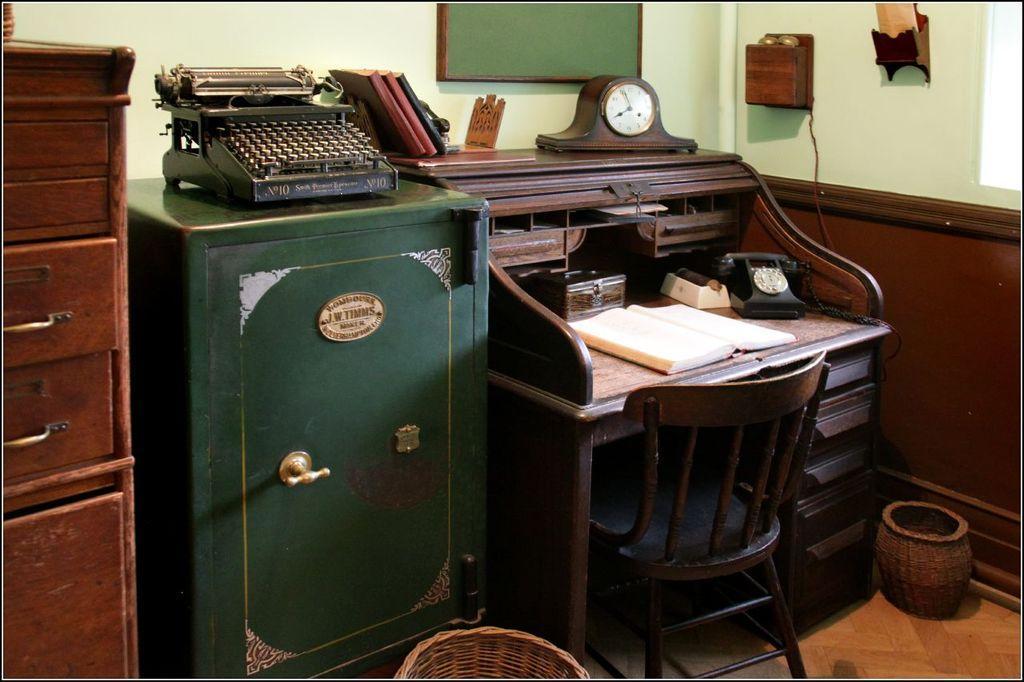Can you describe this image briefly? In this image, we can see a wooden table. the few items are placed on it. There is a wooden chair. Right side we can see basket. And the coming to the background, we can see green. On left side we can see cupboard, wooden cupboard and. The top of the green color cupboard, we can see printing machine. 